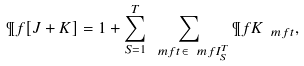<formula> <loc_0><loc_0><loc_500><loc_500>\P f [ J + K ] = 1 + \sum _ { S = 1 } ^ { T } \sum _ { \ m f { t } \in \ m f { I } _ { S } ^ { T } } \P f K _ { \ m f { t } } ,</formula> 